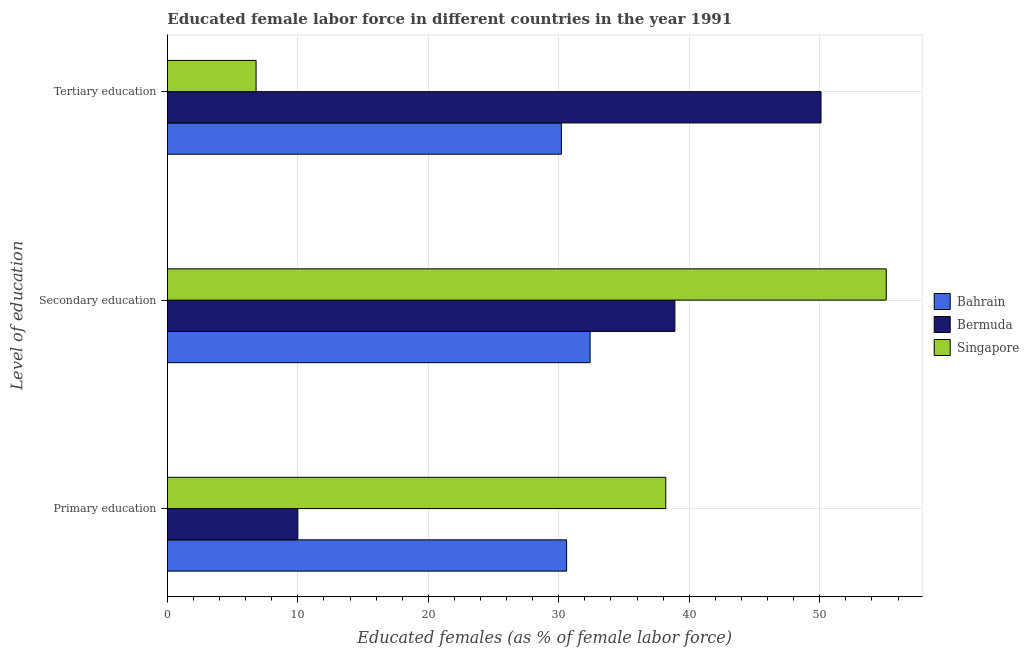How many different coloured bars are there?
Your response must be concise. 3. How many groups of bars are there?
Ensure brevity in your answer.  3. What is the label of the 1st group of bars from the top?
Offer a terse response. Tertiary education. What is the percentage of female labor force who received secondary education in Bermuda?
Your answer should be compact. 38.9. Across all countries, what is the maximum percentage of female labor force who received secondary education?
Give a very brief answer. 55.1. Across all countries, what is the minimum percentage of female labor force who received secondary education?
Your answer should be very brief. 32.4. In which country was the percentage of female labor force who received tertiary education maximum?
Provide a succinct answer. Bermuda. In which country was the percentage of female labor force who received primary education minimum?
Ensure brevity in your answer.  Bermuda. What is the total percentage of female labor force who received secondary education in the graph?
Keep it short and to the point. 126.4. What is the difference between the percentage of female labor force who received secondary education in Bahrain and that in Bermuda?
Make the answer very short. -6.5. What is the difference between the percentage of female labor force who received primary education in Singapore and the percentage of female labor force who received tertiary education in Bahrain?
Your response must be concise. 8. What is the average percentage of female labor force who received primary education per country?
Make the answer very short. 26.27. What is the difference between the percentage of female labor force who received primary education and percentage of female labor force who received tertiary education in Bahrain?
Offer a very short reply. 0.4. What is the ratio of the percentage of female labor force who received tertiary education in Singapore to that in Bahrain?
Provide a short and direct response. 0.23. Is the percentage of female labor force who received primary education in Bermuda less than that in Bahrain?
Make the answer very short. Yes. What is the difference between the highest and the second highest percentage of female labor force who received secondary education?
Offer a terse response. 16.2. What is the difference between the highest and the lowest percentage of female labor force who received primary education?
Give a very brief answer. 28.2. Is the sum of the percentage of female labor force who received tertiary education in Bermuda and Singapore greater than the maximum percentage of female labor force who received secondary education across all countries?
Your answer should be very brief. Yes. What does the 1st bar from the top in Secondary education represents?
Provide a succinct answer. Singapore. What does the 1st bar from the bottom in Tertiary education represents?
Your response must be concise. Bahrain. How many countries are there in the graph?
Provide a succinct answer. 3. Are the values on the major ticks of X-axis written in scientific E-notation?
Ensure brevity in your answer.  No. Does the graph contain grids?
Ensure brevity in your answer.  Yes. How many legend labels are there?
Your answer should be very brief. 3. How are the legend labels stacked?
Provide a short and direct response. Vertical. What is the title of the graph?
Provide a succinct answer. Educated female labor force in different countries in the year 1991. Does "Morocco" appear as one of the legend labels in the graph?
Keep it short and to the point. No. What is the label or title of the X-axis?
Keep it short and to the point. Educated females (as % of female labor force). What is the label or title of the Y-axis?
Provide a short and direct response. Level of education. What is the Educated females (as % of female labor force) in Bahrain in Primary education?
Give a very brief answer. 30.6. What is the Educated females (as % of female labor force) in Singapore in Primary education?
Provide a short and direct response. 38.2. What is the Educated females (as % of female labor force) of Bahrain in Secondary education?
Keep it short and to the point. 32.4. What is the Educated females (as % of female labor force) of Bermuda in Secondary education?
Your answer should be compact. 38.9. What is the Educated females (as % of female labor force) in Singapore in Secondary education?
Offer a terse response. 55.1. What is the Educated females (as % of female labor force) in Bahrain in Tertiary education?
Offer a very short reply. 30.2. What is the Educated females (as % of female labor force) of Bermuda in Tertiary education?
Offer a very short reply. 50.1. What is the Educated females (as % of female labor force) of Singapore in Tertiary education?
Provide a short and direct response. 6.8. Across all Level of education, what is the maximum Educated females (as % of female labor force) in Bahrain?
Ensure brevity in your answer.  32.4. Across all Level of education, what is the maximum Educated females (as % of female labor force) of Bermuda?
Your response must be concise. 50.1. Across all Level of education, what is the maximum Educated females (as % of female labor force) of Singapore?
Ensure brevity in your answer.  55.1. Across all Level of education, what is the minimum Educated females (as % of female labor force) of Bahrain?
Keep it short and to the point. 30.2. Across all Level of education, what is the minimum Educated females (as % of female labor force) in Bermuda?
Make the answer very short. 10. Across all Level of education, what is the minimum Educated females (as % of female labor force) in Singapore?
Offer a very short reply. 6.8. What is the total Educated females (as % of female labor force) of Bahrain in the graph?
Make the answer very short. 93.2. What is the total Educated females (as % of female labor force) in Bermuda in the graph?
Ensure brevity in your answer.  99. What is the total Educated females (as % of female labor force) in Singapore in the graph?
Your answer should be compact. 100.1. What is the difference between the Educated females (as % of female labor force) in Bahrain in Primary education and that in Secondary education?
Your answer should be compact. -1.8. What is the difference between the Educated females (as % of female labor force) of Bermuda in Primary education and that in Secondary education?
Provide a succinct answer. -28.9. What is the difference between the Educated females (as % of female labor force) in Singapore in Primary education and that in Secondary education?
Your answer should be compact. -16.9. What is the difference between the Educated females (as % of female labor force) of Bahrain in Primary education and that in Tertiary education?
Give a very brief answer. 0.4. What is the difference between the Educated females (as % of female labor force) in Bermuda in Primary education and that in Tertiary education?
Your answer should be compact. -40.1. What is the difference between the Educated females (as % of female labor force) of Singapore in Primary education and that in Tertiary education?
Offer a terse response. 31.4. What is the difference between the Educated females (as % of female labor force) of Singapore in Secondary education and that in Tertiary education?
Offer a terse response. 48.3. What is the difference between the Educated females (as % of female labor force) in Bahrain in Primary education and the Educated females (as % of female labor force) in Singapore in Secondary education?
Keep it short and to the point. -24.5. What is the difference between the Educated females (as % of female labor force) in Bermuda in Primary education and the Educated females (as % of female labor force) in Singapore in Secondary education?
Your answer should be compact. -45.1. What is the difference between the Educated females (as % of female labor force) of Bahrain in Primary education and the Educated females (as % of female labor force) of Bermuda in Tertiary education?
Your response must be concise. -19.5. What is the difference between the Educated females (as % of female labor force) of Bahrain in Primary education and the Educated females (as % of female labor force) of Singapore in Tertiary education?
Offer a terse response. 23.8. What is the difference between the Educated females (as % of female labor force) in Bermuda in Primary education and the Educated females (as % of female labor force) in Singapore in Tertiary education?
Offer a very short reply. 3.2. What is the difference between the Educated females (as % of female labor force) in Bahrain in Secondary education and the Educated females (as % of female labor force) in Bermuda in Tertiary education?
Offer a terse response. -17.7. What is the difference between the Educated females (as % of female labor force) in Bahrain in Secondary education and the Educated females (as % of female labor force) in Singapore in Tertiary education?
Your answer should be very brief. 25.6. What is the difference between the Educated females (as % of female labor force) in Bermuda in Secondary education and the Educated females (as % of female labor force) in Singapore in Tertiary education?
Your answer should be very brief. 32.1. What is the average Educated females (as % of female labor force) in Bahrain per Level of education?
Provide a short and direct response. 31.07. What is the average Educated females (as % of female labor force) in Singapore per Level of education?
Offer a terse response. 33.37. What is the difference between the Educated females (as % of female labor force) in Bahrain and Educated females (as % of female labor force) in Bermuda in Primary education?
Provide a succinct answer. 20.6. What is the difference between the Educated females (as % of female labor force) of Bermuda and Educated females (as % of female labor force) of Singapore in Primary education?
Your response must be concise. -28.2. What is the difference between the Educated females (as % of female labor force) of Bahrain and Educated females (as % of female labor force) of Bermuda in Secondary education?
Ensure brevity in your answer.  -6.5. What is the difference between the Educated females (as % of female labor force) of Bahrain and Educated females (as % of female labor force) of Singapore in Secondary education?
Give a very brief answer. -22.7. What is the difference between the Educated females (as % of female labor force) of Bermuda and Educated females (as % of female labor force) of Singapore in Secondary education?
Offer a very short reply. -16.2. What is the difference between the Educated females (as % of female labor force) in Bahrain and Educated females (as % of female labor force) in Bermuda in Tertiary education?
Your answer should be very brief. -19.9. What is the difference between the Educated females (as % of female labor force) of Bahrain and Educated females (as % of female labor force) of Singapore in Tertiary education?
Offer a terse response. 23.4. What is the difference between the Educated females (as % of female labor force) of Bermuda and Educated females (as % of female labor force) of Singapore in Tertiary education?
Your answer should be very brief. 43.3. What is the ratio of the Educated females (as % of female labor force) in Bahrain in Primary education to that in Secondary education?
Ensure brevity in your answer.  0.94. What is the ratio of the Educated females (as % of female labor force) of Bermuda in Primary education to that in Secondary education?
Provide a succinct answer. 0.26. What is the ratio of the Educated females (as % of female labor force) of Singapore in Primary education to that in Secondary education?
Offer a terse response. 0.69. What is the ratio of the Educated females (as % of female labor force) in Bahrain in Primary education to that in Tertiary education?
Your answer should be compact. 1.01. What is the ratio of the Educated females (as % of female labor force) in Bermuda in Primary education to that in Tertiary education?
Your answer should be compact. 0.2. What is the ratio of the Educated females (as % of female labor force) of Singapore in Primary education to that in Tertiary education?
Give a very brief answer. 5.62. What is the ratio of the Educated females (as % of female labor force) in Bahrain in Secondary education to that in Tertiary education?
Make the answer very short. 1.07. What is the ratio of the Educated females (as % of female labor force) of Bermuda in Secondary education to that in Tertiary education?
Provide a short and direct response. 0.78. What is the ratio of the Educated females (as % of female labor force) of Singapore in Secondary education to that in Tertiary education?
Your answer should be very brief. 8.1. What is the difference between the highest and the lowest Educated females (as % of female labor force) of Bahrain?
Ensure brevity in your answer.  2.2. What is the difference between the highest and the lowest Educated females (as % of female labor force) of Bermuda?
Your answer should be very brief. 40.1. What is the difference between the highest and the lowest Educated females (as % of female labor force) in Singapore?
Provide a short and direct response. 48.3. 